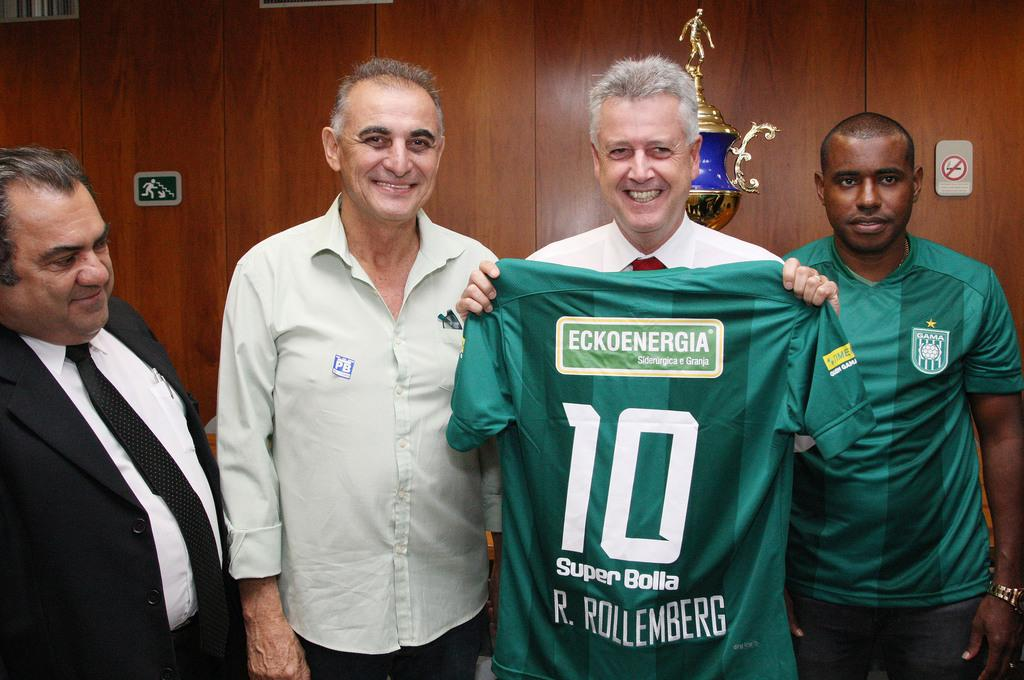<image>
Describe the image concisely. A man holding a green jersey with number 10 Super Bolla written on it 